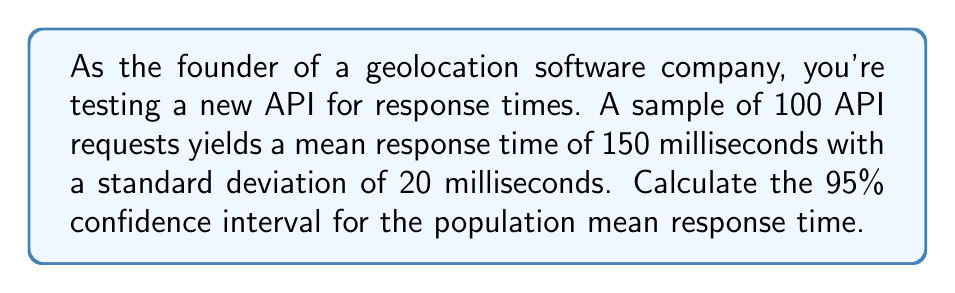Teach me how to tackle this problem. To calculate the confidence interval, we'll follow these steps:

1. Identify the known values:
   - Sample size: $n = 100$
   - Sample mean: $\bar{x} = 150$ ms
   - Sample standard deviation: $s = 20$ ms
   - Confidence level: 95% (α = 0.05)

2. Determine the critical value:
   For a 95% confidence level with a large sample size (n ≥ 30), we use the z-score. The z-score for a 95% confidence interval is 1.96.

3. Calculate the margin of error:
   Margin of error = $z \cdot \frac{s}{\sqrt{n}}$
   $$ \text{Margin of error} = 1.96 \cdot \frac{20}{\sqrt{100}} = 1.96 \cdot 2 = 3.92 \text{ ms} $$

4. Compute the confidence interval:
   Lower bound: $\bar{x} - \text{margin of error}$
   Upper bound: $\bar{x} + \text{margin of error}$

   $$ \text{CI} = 150 \pm 3.92 $$
   $$ \text{CI} = [146.08, 153.92] $$

Therefore, we can be 95% confident that the true population mean response time falls between 146.08 ms and 153.92 ms.
Answer: [146.08, 153.92] ms 